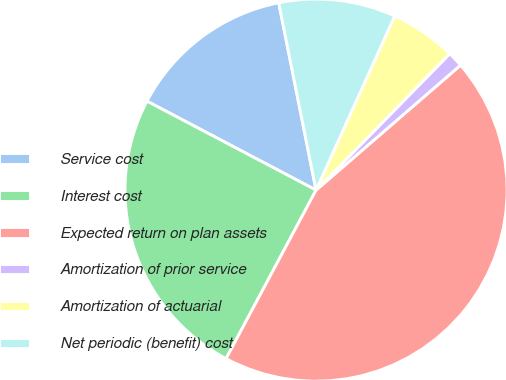Convert chart. <chart><loc_0><loc_0><loc_500><loc_500><pie_chart><fcel>Service cost<fcel>Interest cost<fcel>Expected return on plan assets<fcel>Amortization of prior service<fcel>Amortization of actuarial<fcel>Net periodic (benefit) cost<nl><fcel>14.16%<fcel>24.9%<fcel>44.15%<fcel>1.31%<fcel>5.59%<fcel>9.88%<nl></chart> 